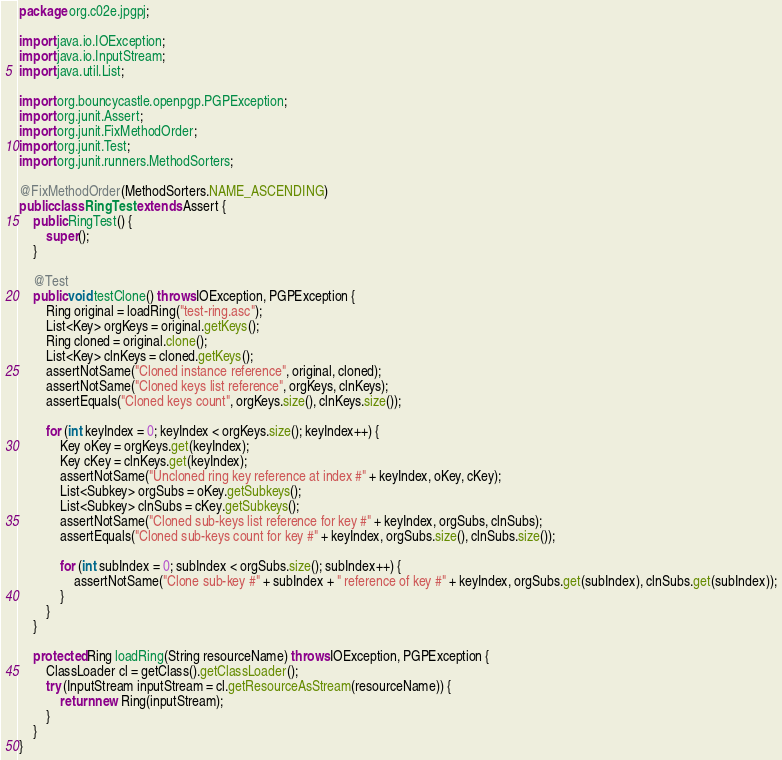<code> <loc_0><loc_0><loc_500><loc_500><_Java_>package org.c02e.jpgpj;

import java.io.IOException;
import java.io.InputStream;
import java.util.List;

import org.bouncycastle.openpgp.PGPException;
import org.junit.Assert;
import org.junit.FixMethodOrder;
import org.junit.Test;
import org.junit.runners.MethodSorters;

@FixMethodOrder(MethodSorters.NAME_ASCENDING)
public class RingTest extends Assert {
    public RingTest() {
        super();
    }

    @Test
    public void testClone() throws IOException, PGPException {
        Ring original = loadRing("test-ring.asc");
        List<Key> orgKeys = original.getKeys();
        Ring cloned = original.clone();
        List<Key> clnKeys = cloned.getKeys();
        assertNotSame("Cloned instance reference", original, cloned);
        assertNotSame("Cloned keys list reference", orgKeys, clnKeys);
        assertEquals("Cloned keys count", orgKeys.size(), clnKeys.size());

        for (int keyIndex = 0; keyIndex < orgKeys.size(); keyIndex++) {
            Key oKey = orgKeys.get(keyIndex);
            Key cKey = clnKeys.get(keyIndex);
            assertNotSame("Uncloned ring key reference at index #" + keyIndex, oKey, cKey);
            List<Subkey> orgSubs = oKey.getSubkeys();
            List<Subkey> clnSubs = cKey.getSubkeys();
            assertNotSame("Cloned sub-keys list reference for key #" + keyIndex, orgSubs, clnSubs);
            assertEquals("Cloned sub-keys count for key #" + keyIndex, orgSubs.size(), clnSubs.size());

            for (int subIndex = 0; subIndex < orgSubs.size(); subIndex++) {
                assertNotSame("Clone sub-key #" + subIndex + " reference of key #" + keyIndex, orgSubs.get(subIndex), clnSubs.get(subIndex));
            }
        }
    }

    protected Ring loadRing(String resourceName) throws IOException, PGPException {
        ClassLoader cl = getClass().getClassLoader();
        try (InputStream inputStream = cl.getResourceAsStream(resourceName)) {
            return new Ring(inputStream);
        }
    }
}
</code> 